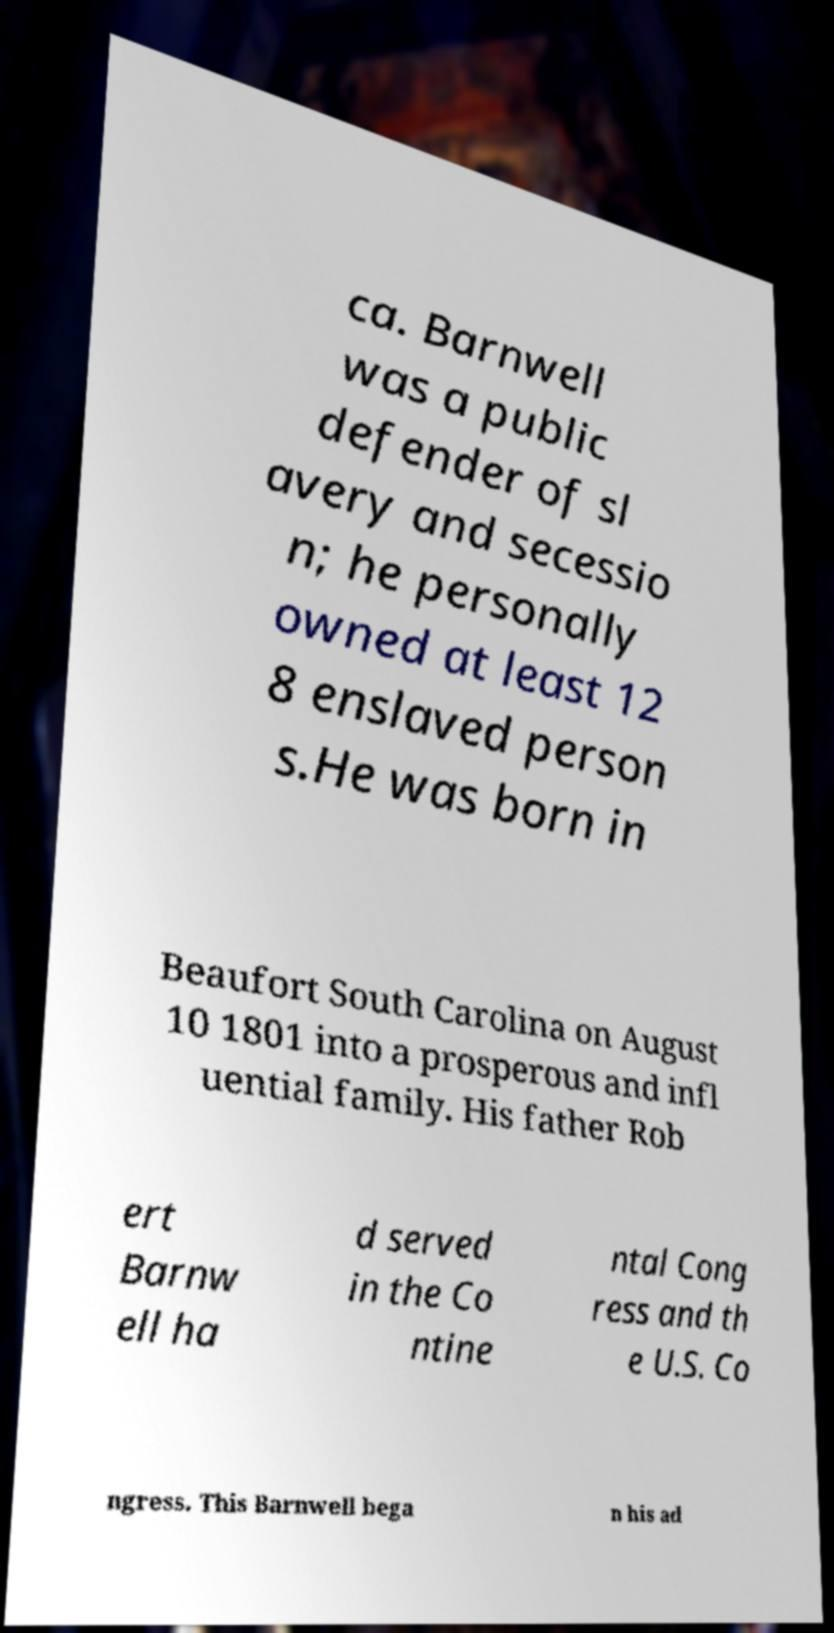There's text embedded in this image that I need extracted. Can you transcribe it verbatim? ca. Barnwell was a public defender of sl avery and secessio n; he personally owned at least 12 8 enslaved person s.He was born in Beaufort South Carolina on August 10 1801 into a prosperous and infl uential family. His father Rob ert Barnw ell ha d served in the Co ntine ntal Cong ress and th e U.S. Co ngress. This Barnwell bega n his ad 